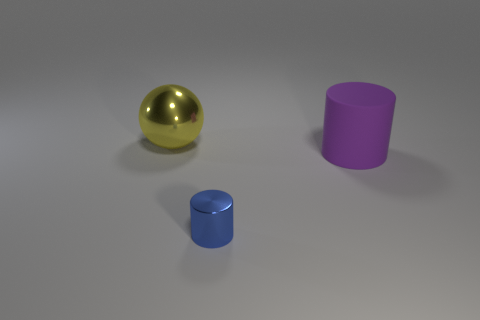What is the color of the shiny object in front of the sphere? The shiny object located in front of the golden sphere appears to be blue and cylindrical in shape, likely reflecting the cool hues of its environment. 